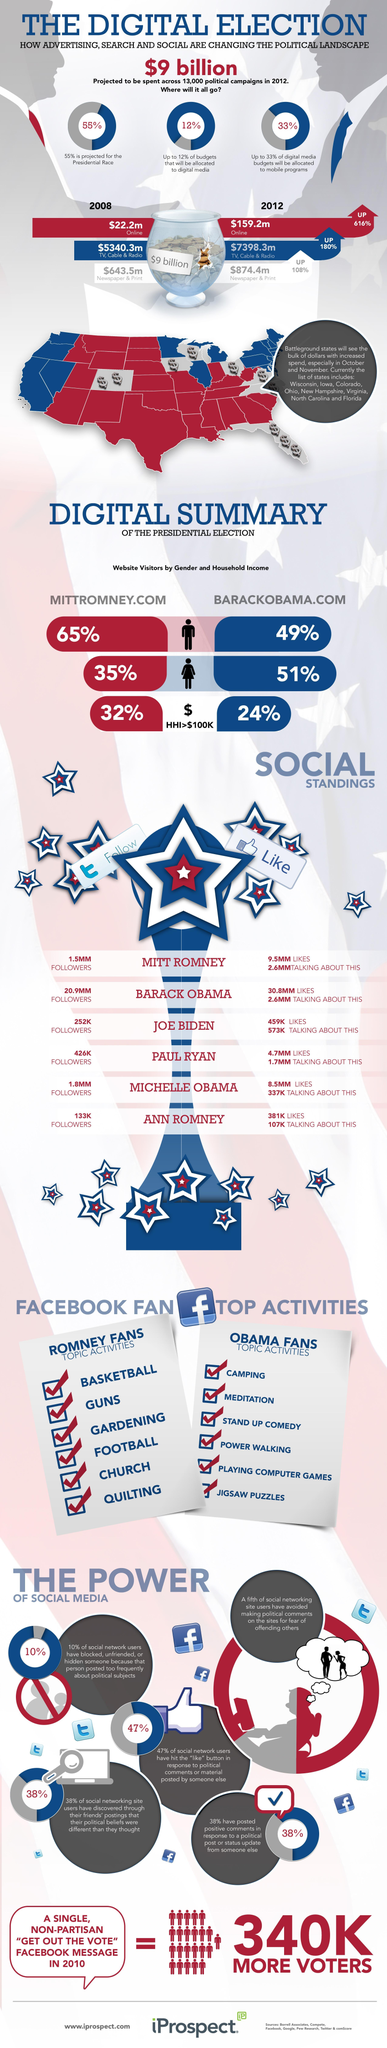How many Facebook likes did Mitt Romney get during the presidential election?
Answer the question with a short phrase. 9.5MM How many people follow Barack Obama on twitter during the presidential election? 20.9MM What percentage of females visited the website 'BARACKOBAMA.COM' during the presidential election? 51% What percentage of males visited the website 'MITTROMNEY.COM' during the presidential election? 65% 